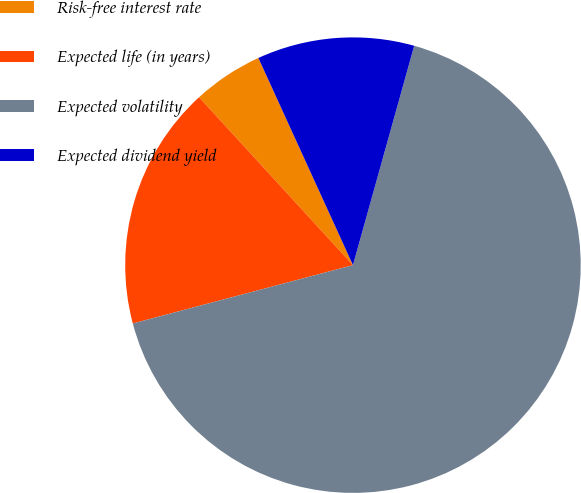Convert chart to OTSL. <chart><loc_0><loc_0><loc_500><loc_500><pie_chart><fcel>Risk-free interest rate<fcel>Expected life (in years)<fcel>Expected volatility<fcel>Expected dividend yield<nl><fcel>4.99%<fcel>17.32%<fcel>66.55%<fcel>11.15%<nl></chart> 